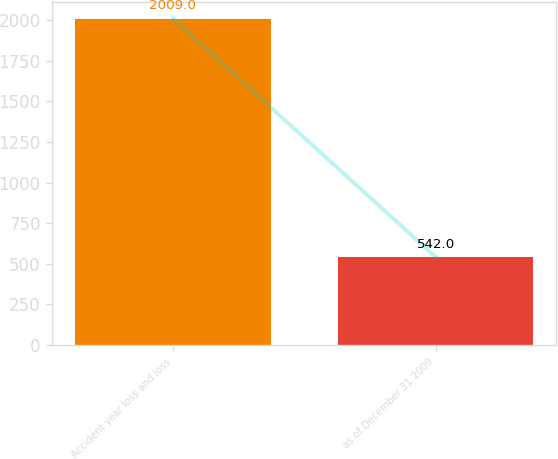<chart> <loc_0><loc_0><loc_500><loc_500><bar_chart><fcel>Accident year loss and loss<fcel>as of December 31 2009<nl><fcel>2009<fcel>542<nl></chart> 